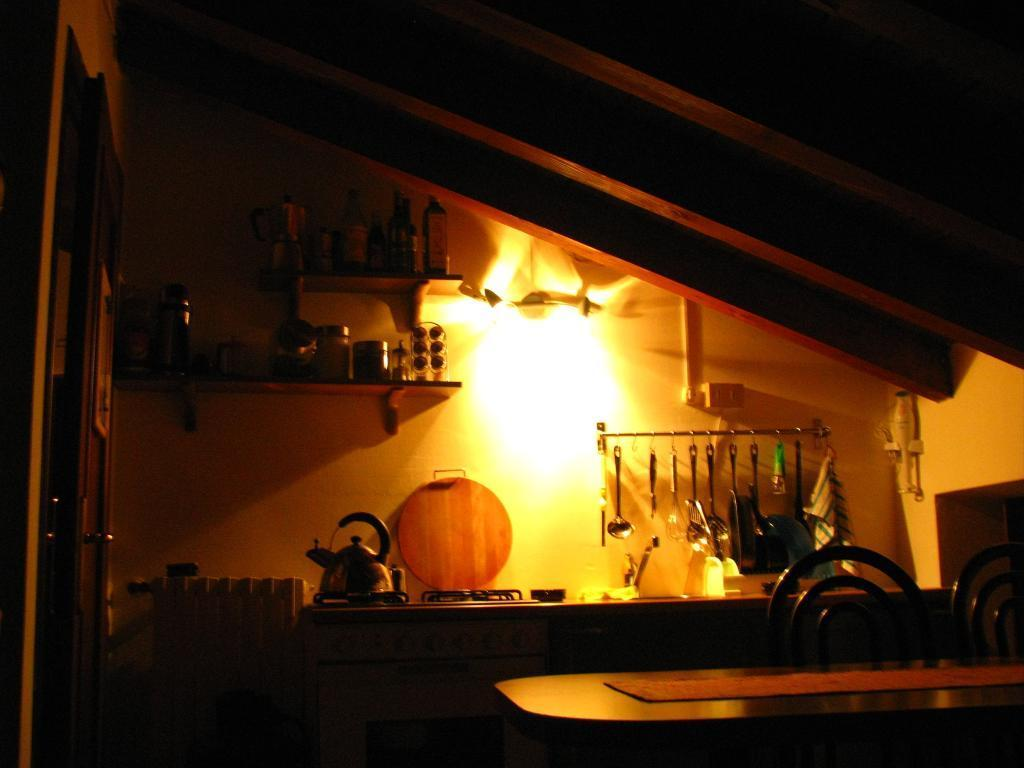What is the setting of the image? The image is set in a kitchen. What can be seen on the left side of the image? There is a tea kettle and a wooden pan on the left side of the image. What utensils are visible on the right side of the image? There are spoons and a knife on the right side of the image. What is located at the top of the image? There are vessels on the top of the image. Can you see a tiger in the kitchen in the image? No, there is no tiger present in the kitchen in the image. What type of love is being expressed in the image? There is no indication of love being expressed in the image, as it features kitchen items and utensils. 